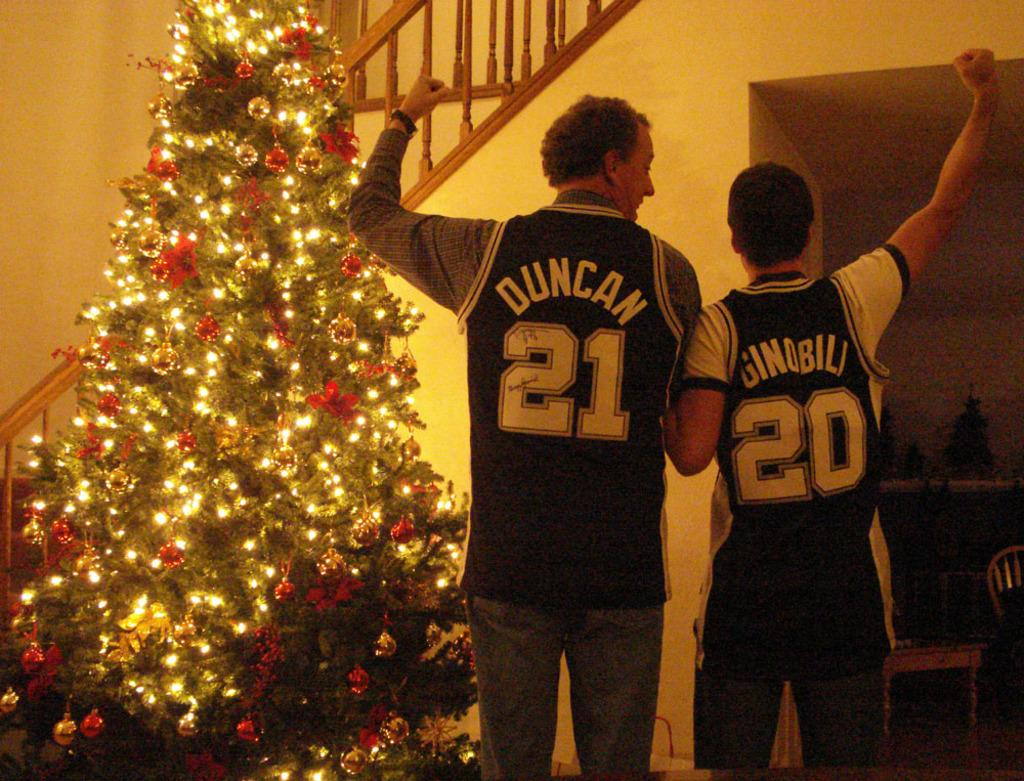<image>
Summarize the visual content of the image. a man and a boy wearing jerseys, one of which is Duncan 